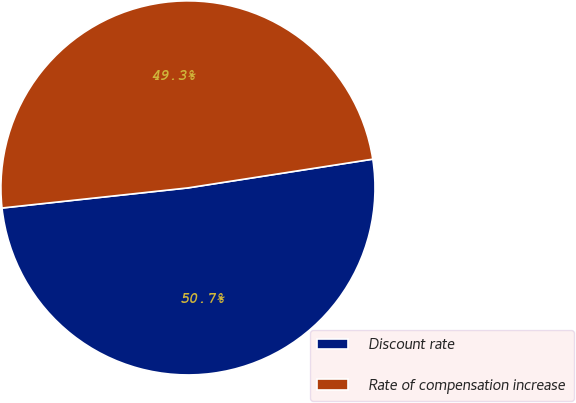Convert chart. <chart><loc_0><loc_0><loc_500><loc_500><pie_chart><fcel>Discount rate<fcel>Rate of compensation increase<nl><fcel>50.74%<fcel>49.26%<nl></chart> 